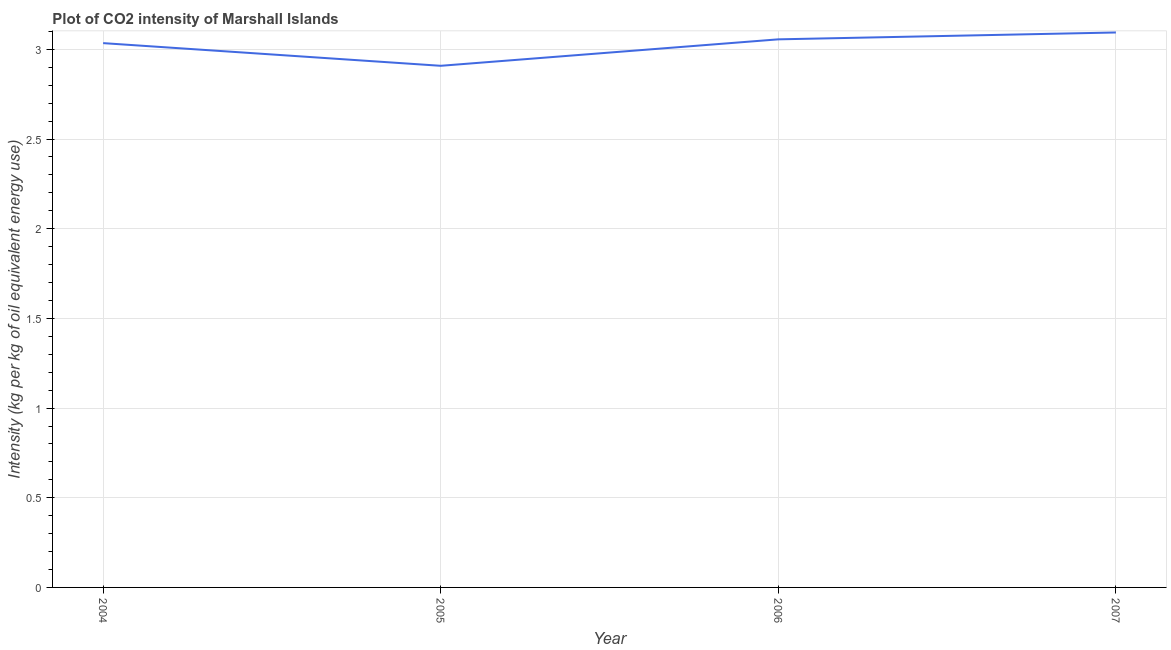What is the co2 intensity in 2004?
Offer a terse response. 3.03. Across all years, what is the maximum co2 intensity?
Give a very brief answer. 3.09. Across all years, what is the minimum co2 intensity?
Your answer should be very brief. 2.91. In which year was the co2 intensity maximum?
Provide a succinct answer. 2007. What is the sum of the co2 intensity?
Ensure brevity in your answer.  12.09. What is the difference between the co2 intensity in 2006 and 2007?
Offer a terse response. -0.04. What is the average co2 intensity per year?
Keep it short and to the point. 3.02. What is the median co2 intensity?
Ensure brevity in your answer.  3.05. In how many years, is the co2 intensity greater than 2.7 kg?
Provide a short and direct response. 4. What is the ratio of the co2 intensity in 2004 to that in 2005?
Offer a very short reply. 1.04. Is the co2 intensity in 2004 less than that in 2005?
Your response must be concise. No. What is the difference between the highest and the second highest co2 intensity?
Give a very brief answer. 0.04. What is the difference between the highest and the lowest co2 intensity?
Your answer should be compact. 0.19. In how many years, is the co2 intensity greater than the average co2 intensity taken over all years?
Make the answer very short. 3. Does the co2 intensity monotonically increase over the years?
Your response must be concise. No. How many years are there in the graph?
Your response must be concise. 4. Are the values on the major ticks of Y-axis written in scientific E-notation?
Your answer should be compact. No. Does the graph contain any zero values?
Keep it short and to the point. No. What is the title of the graph?
Your answer should be very brief. Plot of CO2 intensity of Marshall Islands. What is the label or title of the X-axis?
Give a very brief answer. Year. What is the label or title of the Y-axis?
Ensure brevity in your answer.  Intensity (kg per kg of oil equivalent energy use). What is the Intensity (kg per kg of oil equivalent energy use) in 2004?
Offer a terse response. 3.03. What is the Intensity (kg per kg of oil equivalent energy use) in 2005?
Your response must be concise. 2.91. What is the Intensity (kg per kg of oil equivalent energy use) in 2006?
Provide a short and direct response. 3.06. What is the Intensity (kg per kg of oil equivalent energy use) of 2007?
Your answer should be very brief. 3.09. What is the difference between the Intensity (kg per kg of oil equivalent energy use) in 2004 and 2005?
Your answer should be compact. 0.13. What is the difference between the Intensity (kg per kg of oil equivalent energy use) in 2004 and 2006?
Offer a terse response. -0.02. What is the difference between the Intensity (kg per kg of oil equivalent energy use) in 2004 and 2007?
Your response must be concise. -0.06. What is the difference between the Intensity (kg per kg of oil equivalent energy use) in 2005 and 2006?
Offer a terse response. -0.15. What is the difference between the Intensity (kg per kg of oil equivalent energy use) in 2005 and 2007?
Your response must be concise. -0.19. What is the difference between the Intensity (kg per kg of oil equivalent energy use) in 2006 and 2007?
Your answer should be very brief. -0.04. What is the ratio of the Intensity (kg per kg of oil equivalent energy use) in 2004 to that in 2005?
Your answer should be compact. 1.04. What is the ratio of the Intensity (kg per kg of oil equivalent energy use) in 2004 to that in 2006?
Ensure brevity in your answer.  0.99. What is the ratio of the Intensity (kg per kg of oil equivalent energy use) in 2004 to that in 2007?
Your answer should be compact. 0.98. What is the ratio of the Intensity (kg per kg of oil equivalent energy use) in 2005 to that in 2007?
Your answer should be very brief. 0.94. What is the ratio of the Intensity (kg per kg of oil equivalent energy use) in 2006 to that in 2007?
Ensure brevity in your answer.  0.99. 